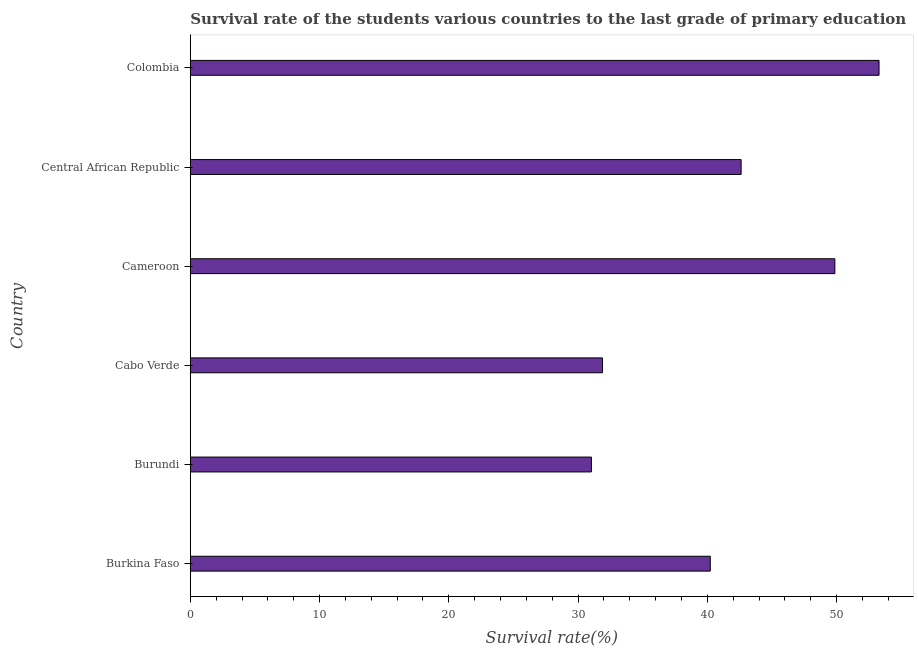What is the title of the graph?
Your answer should be very brief. Survival rate of the students various countries to the last grade of primary education. What is the label or title of the X-axis?
Your response must be concise. Survival rate(%). What is the label or title of the Y-axis?
Your response must be concise. Country. What is the survival rate in primary education in Cabo Verde?
Your answer should be compact. 31.89. Across all countries, what is the maximum survival rate in primary education?
Your answer should be compact. 53.28. Across all countries, what is the minimum survival rate in primary education?
Keep it short and to the point. 31.03. In which country was the survival rate in primary education maximum?
Your answer should be compact. Colombia. In which country was the survival rate in primary education minimum?
Your answer should be compact. Burundi. What is the sum of the survival rate in primary education?
Offer a very short reply. 248.9. What is the difference between the survival rate in primary education in Burundi and Central African Republic?
Your answer should be compact. -11.58. What is the average survival rate in primary education per country?
Make the answer very short. 41.48. What is the median survival rate in primary education?
Offer a very short reply. 41.42. What is the ratio of the survival rate in primary education in Burkina Faso to that in Central African Republic?
Give a very brief answer. 0.94. What is the difference between the highest and the second highest survival rate in primary education?
Keep it short and to the point. 3.42. Is the sum of the survival rate in primary education in Burkina Faso and Cabo Verde greater than the maximum survival rate in primary education across all countries?
Your response must be concise. Yes. What is the difference between the highest and the lowest survival rate in primary education?
Your response must be concise. 22.25. In how many countries, is the survival rate in primary education greater than the average survival rate in primary education taken over all countries?
Offer a terse response. 3. How many bars are there?
Offer a very short reply. 6. Are all the bars in the graph horizontal?
Your answer should be very brief. Yes. How many countries are there in the graph?
Offer a very short reply. 6. Are the values on the major ticks of X-axis written in scientific E-notation?
Offer a very short reply. No. What is the Survival rate(%) in Burkina Faso?
Your answer should be very brief. 40.23. What is the Survival rate(%) in Burundi?
Provide a short and direct response. 31.03. What is the Survival rate(%) of Cabo Verde?
Offer a terse response. 31.89. What is the Survival rate(%) in Cameroon?
Offer a terse response. 49.86. What is the Survival rate(%) in Central African Republic?
Give a very brief answer. 42.61. What is the Survival rate(%) of Colombia?
Offer a terse response. 53.28. What is the difference between the Survival rate(%) in Burkina Faso and Burundi?
Your response must be concise. 9.2. What is the difference between the Survival rate(%) in Burkina Faso and Cabo Verde?
Your answer should be very brief. 8.34. What is the difference between the Survival rate(%) in Burkina Faso and Cameroon?
Provide a short and direct response. -9.64. What is the difference between the Survival rate(%) in Burkina Faso and Central African Republic?
Offer a terse response. -2.39. What is the difference between the Survival rate(%) in Burkina Faso and Colombia?
Provide a succinct answer. -13.06. What is the difference between the Survival rate(%) in Burundi and Cabo Verde?
Give a very brief answer. -0.85. What is the difference between the Survival rate(%) in Burundi and Cameroon?
Your response must be concise. -18.83. What is the difference between the Survival rate(%) in Burundi and Central African Republic?
Your answer should be compact. -11.58. What is the difference between the Survival rate(%) in Burundi and Colombia?
Your response must be concise. -22.25. What is the difference between the Survival rate(%) in Cabo Verde and Cameroon?
Offer a very short reply. -17.98. What is the difference between the Survival rate(%) in Cabo Verde and Central African Republic?
Make the answer very short. -10.73. What is the difference between the Survival rate(%) in Cabo Verde and Colombia?
Give a very brief answer. -21.4. What is the difference between the Survival rate(%) in Cameroon and Central African Republic?
Provide a short and direct response. 7.25. What is the difference between the Survival rate(%) in Cameroon and Colombia?
Make the answer very short. -3.42. What is the difference between the Survival rate(%) in Central African Republic and Colombia?
Offer a very short reply. -10.67. What is the ratio of the Survival rate(%) in Burkina Faso to that in Burundi?
Keep it short and to the point. 1.3. What is the ratio of the Survival rate(%) in Burkina Faso to that in Cabo Verde?
Ensure brevity in your answer.  1.26. What is the ratio of the Survival rate(%) in Burkina Faso to that in Cameroon?
Make the answer very short. 0.81. What is the ratio of the Survival rate(%) in Burkina Faso to that in Central African Republic?
Make the answer very short. 0.94. What is the ratio of the Survival rate(%) in Burkina Faso to that in Colombia?
Keep it short and to the point. 0.76. What is the ratio of the Survival rate(%) in Burundi to that in Cabo Verde?
Offer a terse response. 0.97. What is the ratio of the Survival rate(%) in Burundi to that in Cameroon?
Your response must be concise. 0.62. What is the ratio of the Survival rate(%) in Burundi to that in Central African Republic?
Provide a short and direct response. 0.73. What is the ratio of the Survival rate(%) in Burundi to that in Colombia?
Ensure brevity in your answer.  0.58. What is the ratio of the Survival rate(%) in Cabo Verde to that in Cameroon?
Your answer should be very brief. 0.64. What is the ratio of the Survival rate(%) in Cabo Verde to that in Central African Republic?
Your answer should be compact. 0.75. What is the ratio of the Survival rate(%) in Cabo Verde to that in Colombia?
Your response must be concise. 0.6. What is the ratio of the Survival rate(%) in Cameroon to that in Central African Republic?
Keep it short and to the point. 1.17. What is the ratio of the Survival rate(%) in Cameroon to that in Colombia?
Offer a terse response. 0.94. What is the ratio of the Survival rate(%) in Central African Republic to that in Colombia?
Offer a terse response. 0.8. 